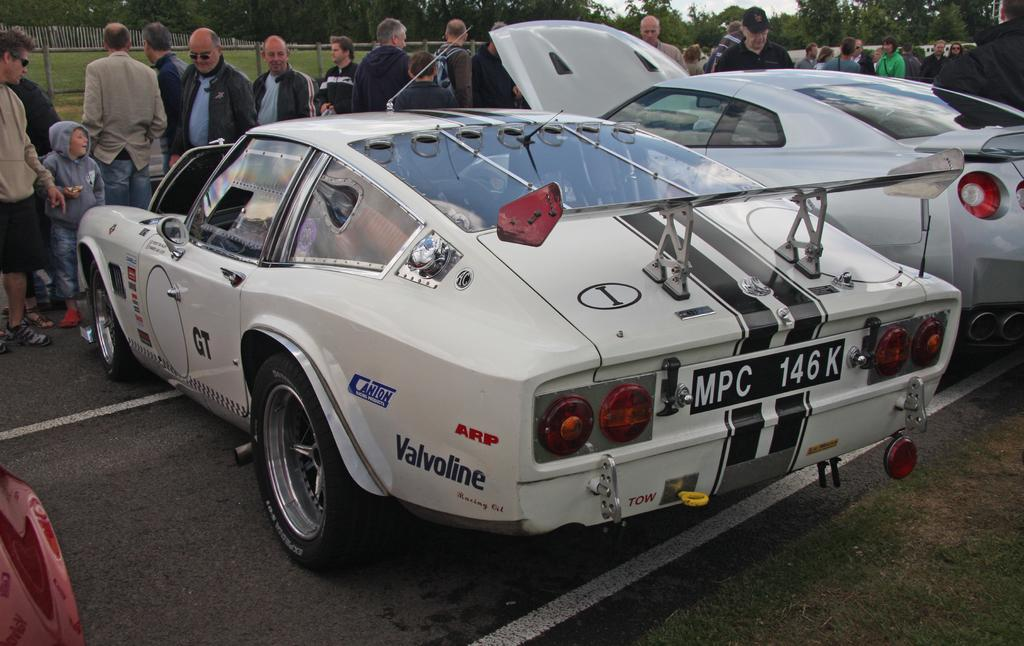What can be seen on the road in the image? There are cars on the road in the image. Where are the people located in the image? There is a group of people standing on the backside in the image. What type of barrier is visible in the image? There is a fence visible in the image. What type of vegetation is present in the image? Grass is present in the image, and trees are visible as well. What is visible above the scene in the image? The sky is visible in the image. What type of quarter is being used to cut the trees in the image? There is no quarter present in the image, nor are any trees being cut. What type of agreement is being discussed by the group of people in the image? There is no indication of any agreement being discussed by the group of people in the image. 